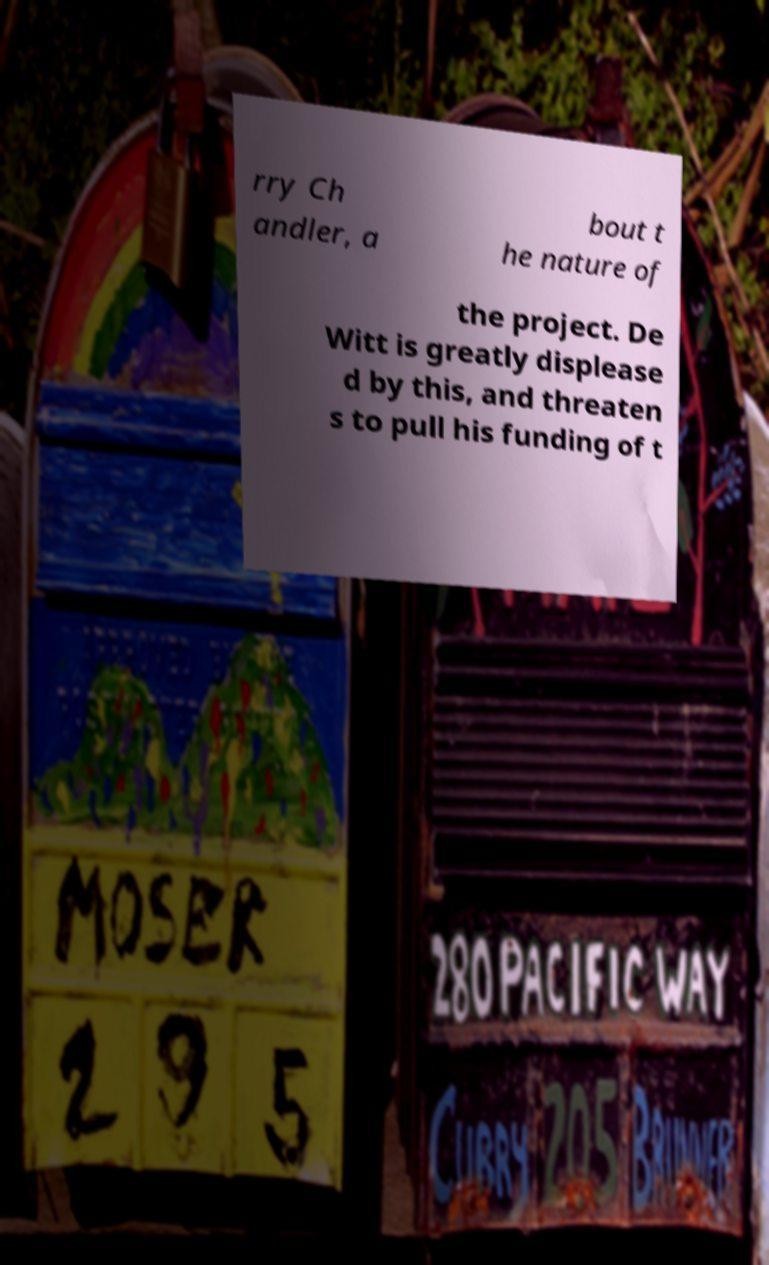There's text embedded in this image that I need extracted. Can you transcribe it verbatim? rry Ch andler, a bout t he nature of the project. De Witt is greatly displease d by this, and threaten s to pull his funding of t 